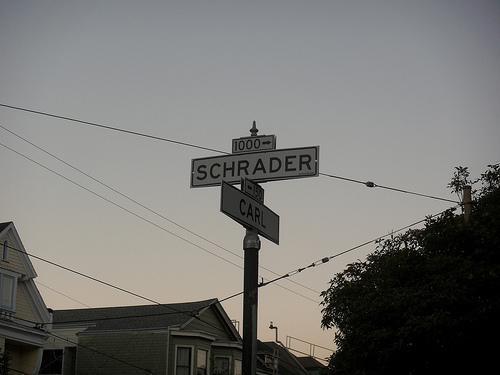How many street names are shown?
Give a very brief answer. 2. 